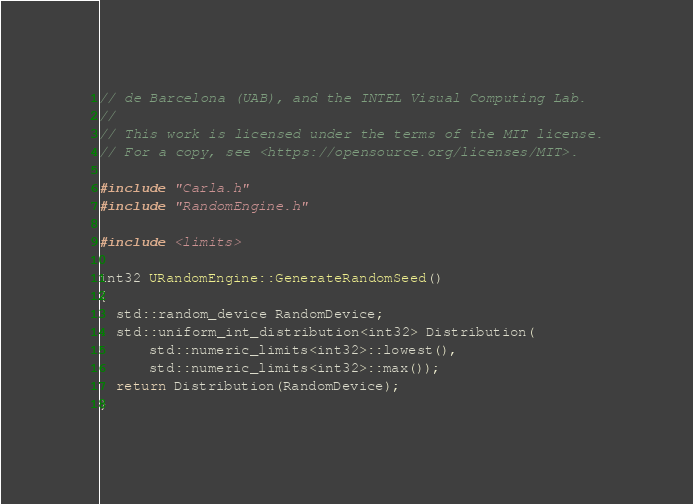<code> <loc_0><loc_0><loc_500><loc_500><_C++_>// de Barcelona (UAB), and the INTEL Visual Computing Lab.
//
// This work is licensed under the terms of the MIT license.
// For a copy, see <https://opensource.org/licenses/MIT>.

#include "Carla.h"
#include "RandomEngine.h"

#include <limits>

int32 URandomEngine::GenerateRandomSeed()
{
  std::random_device RandomDevice;
  std::uniform_int_distribution<int32> Distribution(
      std::numeric_limits<int32>::lowest(),
      std::numeric_limits<int32>::max());
  return Distribution(RandomDevice);
}
</code> 